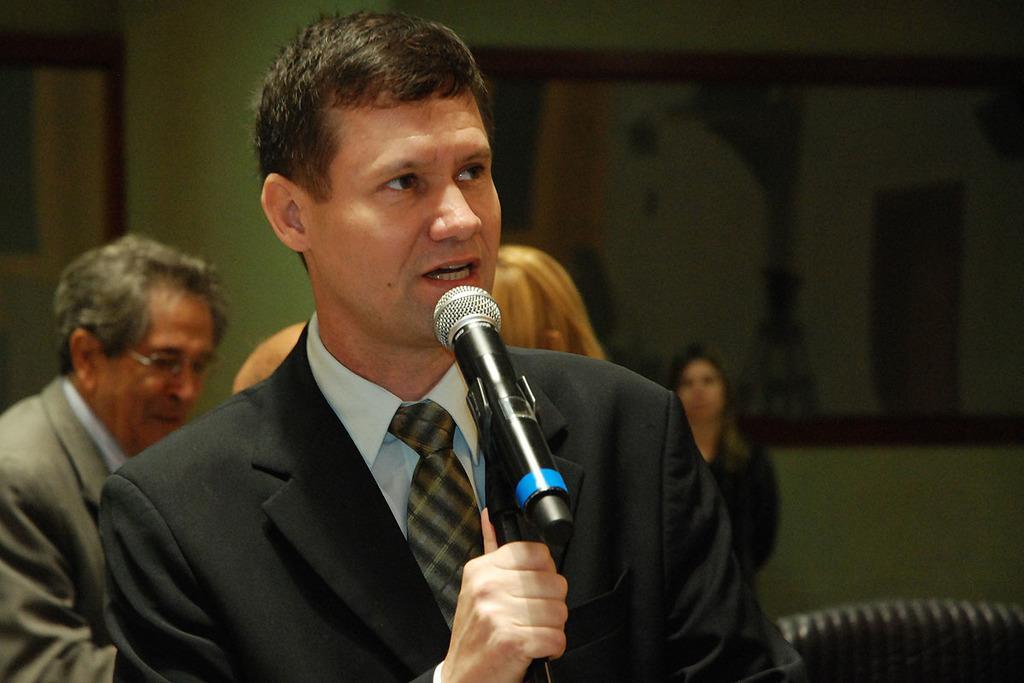Can you describe this image briefly? In this Image I see a man who is holding a mic and I can also see he is wearing a suit. In the background I see few people. 